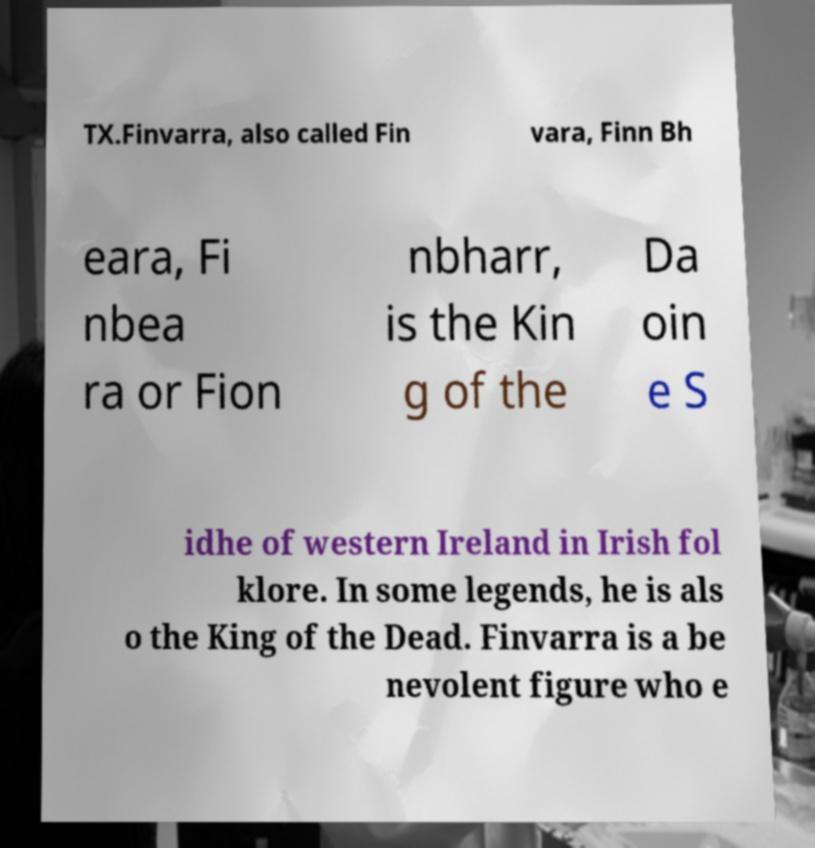Could you assist in decoding the text presented in this image and type it out clearly? TX.Finvarra, also called Fin vara, Finn Bh eara, Fi nbea ra or Fion nbharr, is the Kin g of the Da oin e S idhe of western Ireland in Irish fol klore. In some legends, he is als o the King of the Dead. Finvarra is a be nevolent figure who e 